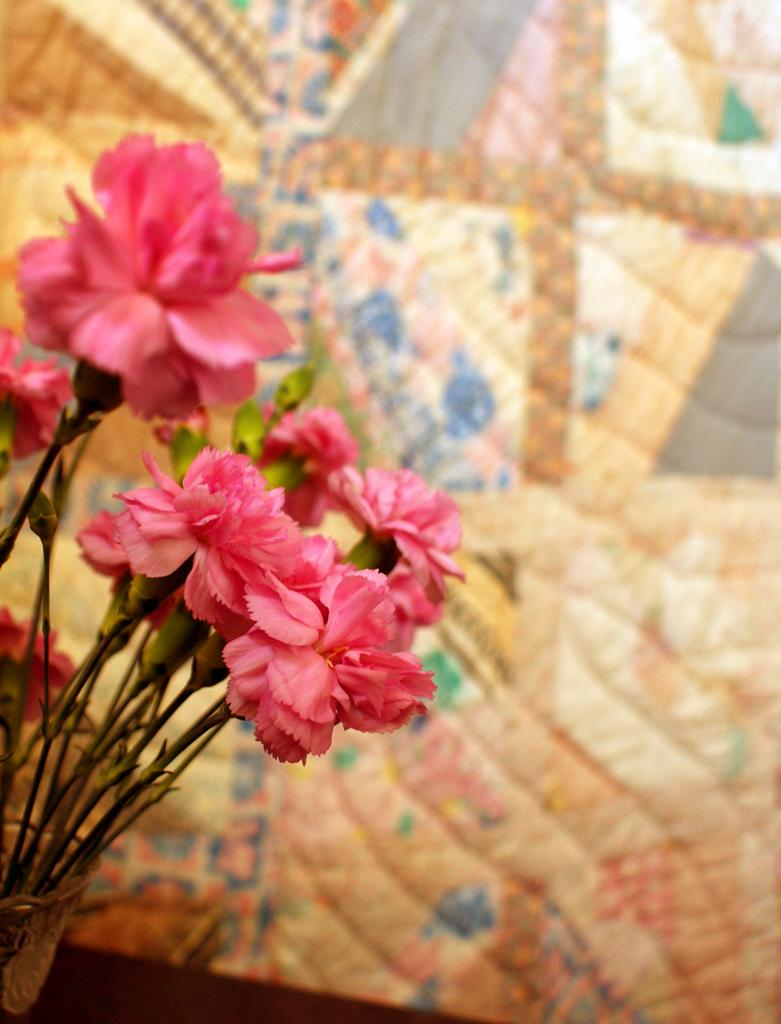What is the main subject in the center of the image? There are flowers in the center of the image. What can be seen in the background of the image? There is cloth visible in the background of the image. How does the ground appear in the image? There is no ground visible in the image; it only features flowers and cloth. 